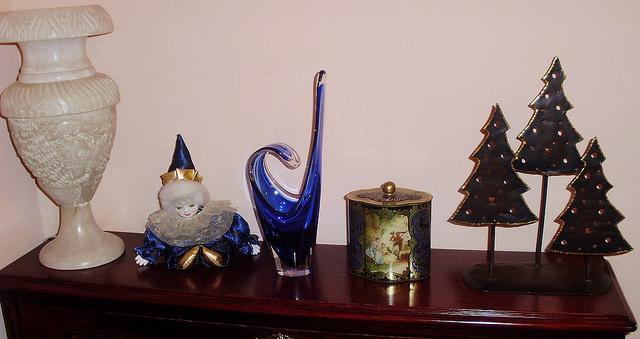How many trees on the table?
Give a very brief answer. 3. How many horns are in the picture?
Give a very brief answer. 0. How many vases are visible?
Give a very brief answer. 2. 